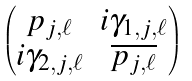Convert formula to latex. <formula><loc_0><loc_0><loc_500><loc_500>\begin{pmatrix} p _ { j , \ell } & i \gamma _ { 1 , j , \ell } \\ i \gamma _ { 2 , j , \ell } & \overline { p _ { j , \ell } } \end{pmatrix}</formula> 